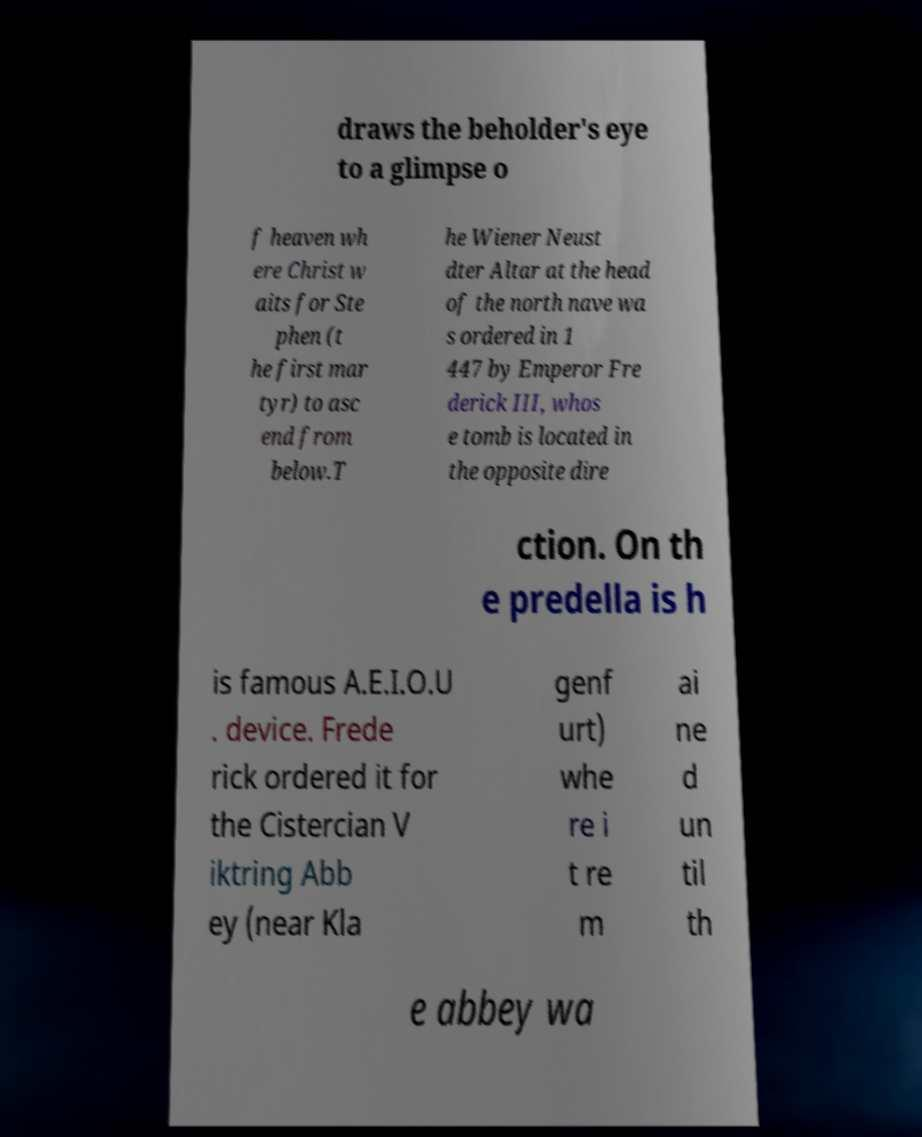Can you read and provide the text displayed in the image?This photo seems to have some interesting text. Can you extract and type it out for me? draws the beholder's eye to a glimpse o f heaven wh ere Christ w aits for Ste phen (t he first mar tyr) to asc end from below.T he Wiener Neust dter Altar at the head of the north nave wa s ordered in 1 447 by Emperor Fre derick III, whos e tomb is located in the opposite dire ction. On th e predella is h is famous A.E.I.O.U . device. Frede rick ordered it for the Cistercian V iktring Abb ey (near Kla genf urt) whe re i t re m ai ne d un til th e abbey wa 